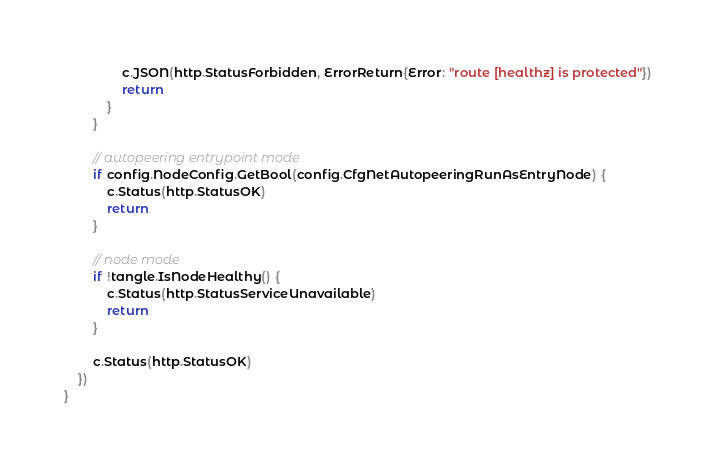<code> <loc_0><loc_0><loc_500><loc_500><_Go_>				c.JSON(http.StatusForbidden, ErrorReturn{Error: "route [healthz] is protected"})
				return
			}
		}

		// autopeering entrypoint mode
		if config.NodeConfig.GetBool(config.CfgNetAutopeeringRunAsEntryNode) {
			c.Status(http.StatusOK)
			return
		}

		// node mode
		if !tangle.IsNodeHealthy() {
			c.Status(http.StatusServiceUnavailable)
			return
		}

		c.Status(http.StatusOK)
	})
}
</code> 